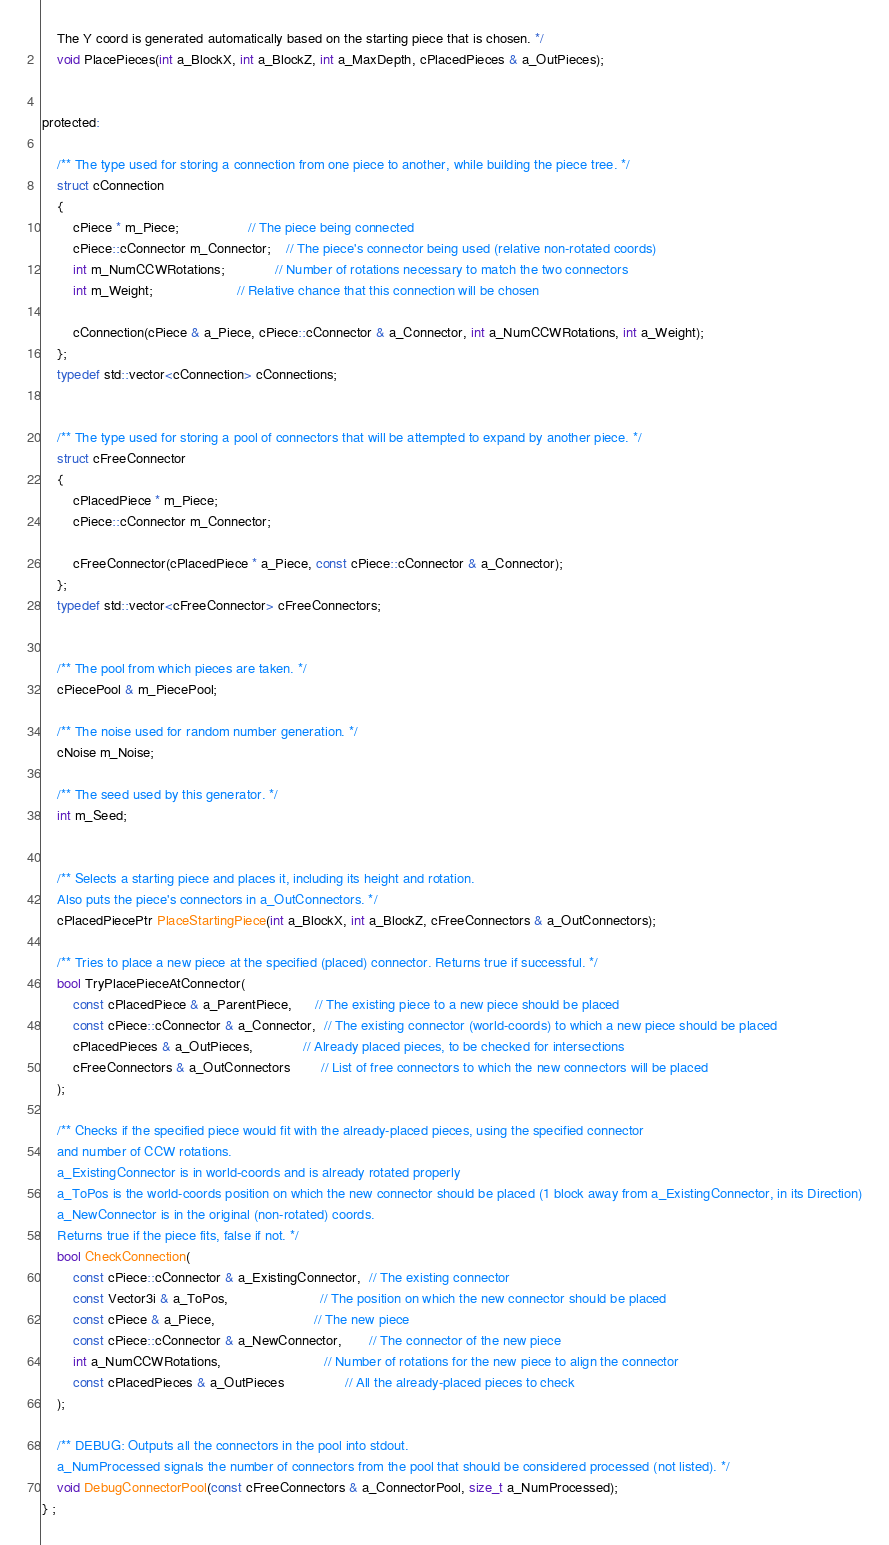Convert code to text. <code><loc_0><loc_0><loc_500><loc_500><_C_>	The Y coord is generated automatically based on the starting piece that is chosen. */
	void PlacePieces(int a_BlockX, int a_BlockZ, int a_MaxDepth, cPlacedPieces & a_OutPieces);


protected:

	/** The type used for storing a connection from one piece to another, while building the piece tree. */
	struct cConnection
	{
		cPiece * m_Piece;                  // The piece being connected
		cPiece::cConnector m_Connector;    // The piece's connector being used (relative non-rotated coords)
		int m_NumCCWRotations;             // Number of rotations necessary to match the two connectors
		int m_Weight;                      // Relative chance that this connection will be chosen

		cConnection(cPiece & a_Piece, cPiece::cConnector & a_Connector, int a_NumCCWRotations, int a_Weight);
	};
	typedef std::vector<cConnection> cConnections;


	/** The type used for storing a pool of connectors that will be attempted to expand by another piece. */
	struct cFreeConnector
	{
		cPlacedPiece * m_Piece;
		cPiece::cConnector m_Connector;

		cFreeConnector(cPlacedPiece * a_Piece, const cPiece::cConnector & a_Connector);
	};
	typedef std::vector<cFreeConnector> cFreeConnectors;


	/** The pool from which pieces are taken. */
	cPiecePool & m_PiecePool;

	/** The noise used for random number generation. */
	cNoise m_Noise;

	/** The seed used by this generator. */
	int m_Seed;


	/** Selects a starting piece and places it, including its height and rotation.
	Also puts the piece's connectors in a_OutConnectors. */
	cPlacedPiecePtr PlaceStartingPiece(int a_BlockX, int a_BlockZ, cFreeConnectors & a_OutConnectors);

	/** Tries to place a new piece at the specified (placed) connector. Returns true if successful. */
	bool TryPlacePieceAtConnector(
		const cPlacedPiece & a_ParentPiece,      // The existing piece to a new piece should be placed
		const cPiece::cConnector & a_Connector,  // The existing connector (world-coords) to which a new piece should be placed
		cPlacedPieces & a_OutPieces,             // Already placed pieces, to be checked for intersections
		cFreeConnectors & a_OutConnectors        // List of free connectors to which the new connectors will be placed
	);

	/** Checks if the specified piece would fit with the already-placed pieces, using the specified connector
	and number of CCW rotations.
	a_ExistingConnector is in world-coords and is already rotated properly
	a_ToPos is the world-coords position on which the new connector should be placed (1 block away from a_ExistingConnector, in its Direction)
	a_NewConnector is in the original (non-rotated) coords.
	Returns true if the piece fits, false if not. */
	bool CheckConnection(
		const cPiece::cConnector & a_ExistingConnector,  // The existing connector
		const Vector3i & a_ToPos,                        // The position on which the new connector should be placed
		const cPiece & a_Piece,                          // The new piece
		const cPiece::cConnector & a_NewConnector,       // The connector of the new piece
		int a_NumCCWRotations,                           // Number of rotations for the new piece to align the connector
		const cPlacedPieces & a_OutPieces                // All the already-placed pieces to check
	);

	/** DEBUG: Outputs all the connectors in the pool into stdout.
	a_NumProcessed signals the number of connectors from the pool that should be considered processed (not listed). */
	void DebugConnectorPool(const cFreeConnectors & a_ConnectorPool, size_t a_NumProcessed);
} ;




</code> 